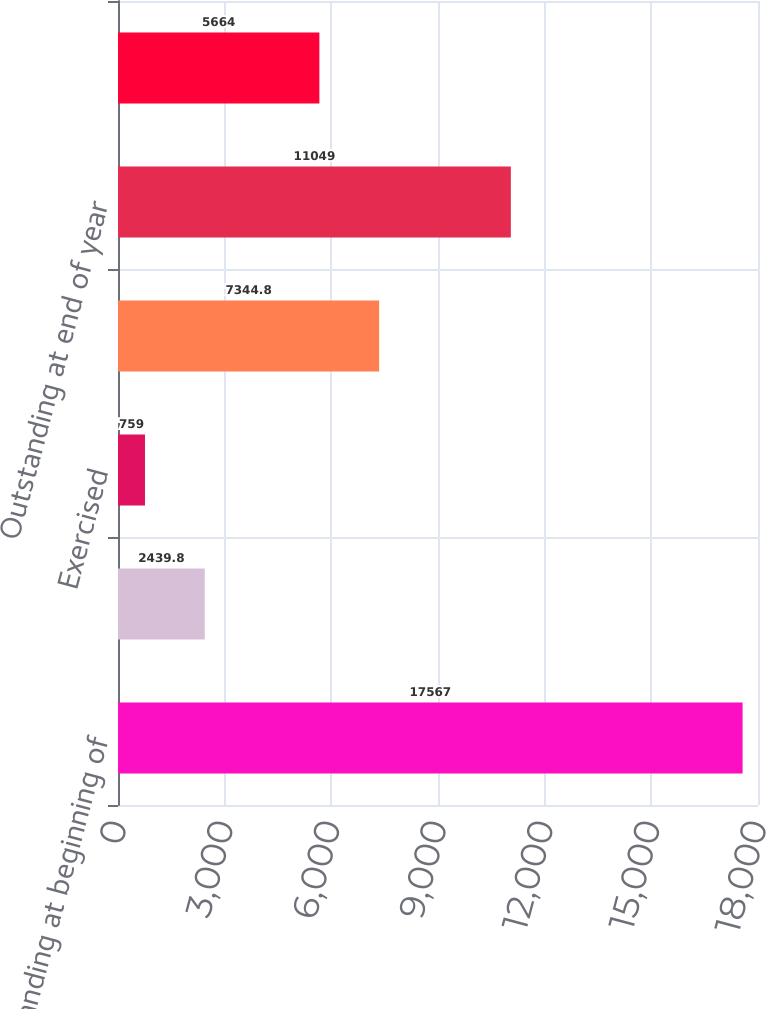Convert chart to OTSL. <chart><loc_0><loc_0><loc_500><loc_500><bar_chart><fcel>Outstanding at beginning of<fcel>Granted<fcel>Exercised<fcel>Terminated<fcel>Outstanding at end of year<fcel>Exercisable at end of year<nl><fcel>17567<fcel>2439.8<fcel>759<fcel>7344.8<fcel>11049<fcel>5664<nl></chart> 